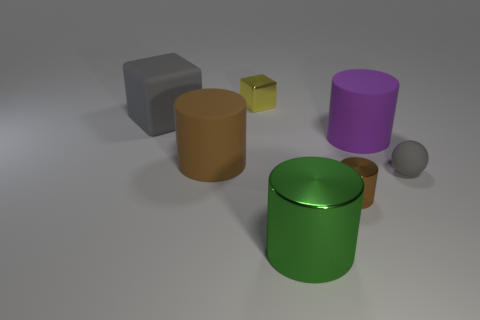There is a gray matte thing that is right of the green cylinder; what is its shape?
Offer a terse response. Sphere. How many big metal objects are the same shape as the small brown thing?
Provide a short and direct response. 1. Do the tiny metal thing that is in front of the tiny rubber sphere and the big matte cylinder on the left side of the brown shiny cylinder have the same color?
Keep it short and to the point. Yes. What number of objects are tiny objects or small yellow metal balls?
Your answer should be very brief. 3. How many gray spheres have the same material as the yellow block?
Your answer should be very brief. 0. Are there fewer large green objects than brown metallic balls?
Offer a terse response. No. Are the block that is right of the big cube and the gray ball made of the same material?
Offer a very short reply. No. How many spheres are either yellow shiny things or tiny rubber things?
Offer a terse response. 1. There is a rubber thing that is to the right of the big gray rubber cube and to the left of the tiny cube; what shape is it?
Give a very brief answer. Cylinder. What is the color of the large matte object to the left of the brown cylinder to the left of the small metal object that is behind the small ball?
Your answer should be compact. Gray. 